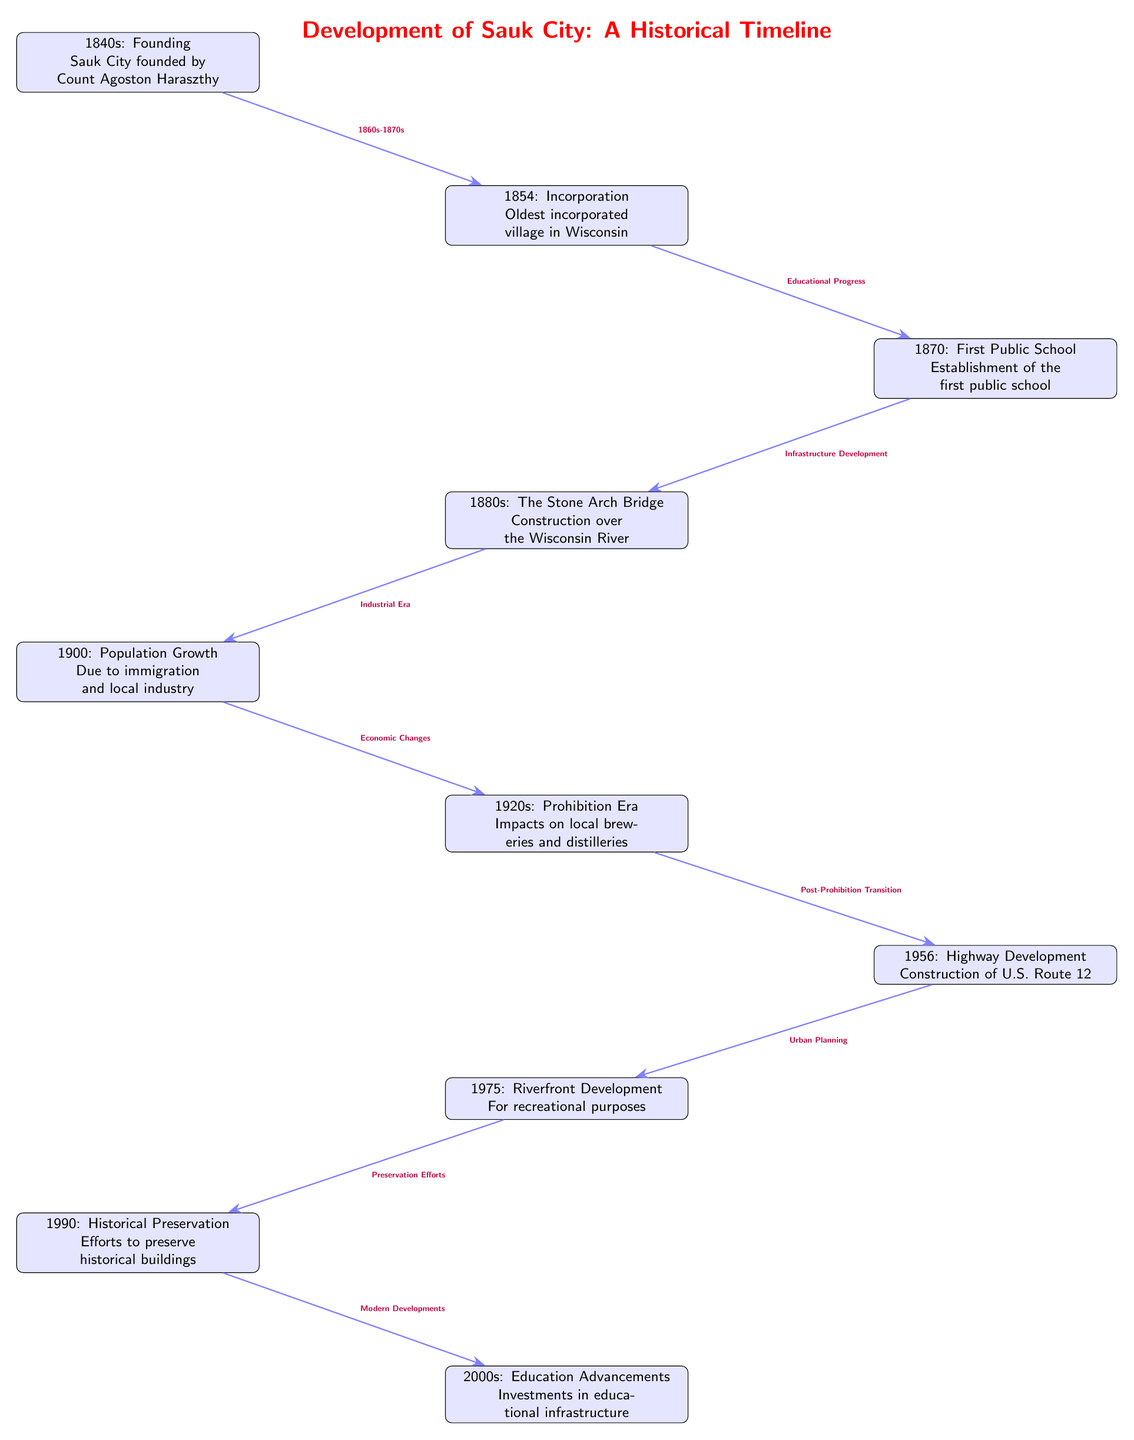What event marks the founding of Sauk City? The diagram identifies "1840s: Founding" as the event marking the founding, attributed to Count Agoston Haraszthy.
Answer: Founding When was Sauk City incorporated? According to the diagram, Sauk City was incorporated in "1854".
Answer: 1854 What was the first public institution established in Sauk City? The diagram states that "1870: First Public School" marks the establishment of the first public school in the city.
Answer: First Public School Which significant construction occurred in the 1880s? The diagram notes "1880s: The Stone Arch Bridge" as a major construction project that took place over the Wisconsin River.
Answer: The Stone Arch Bridge How did immigration impact Sauk City around 1900? The diagram explains "1900: Population Growth" due to immigration and local industry as a significant factor in the city's growth at that time.
Answer: Population Growth What development occurred in Sauk City in the 1950s? The diagram highlights "1956: Highway Development" as a notable event with the construction of U.S. Route 12.
Answer: Highway Development What were the effects of the 1920s on local businesses? The diagram states that during the "1920s: Prohibition Era", local breweries and distilleries were impacted.
Answer: Impacts on local breweries and distilleries What progression of events connects public education to infrastructure? In the diagram, the flow is from "1854: Incorporation" leading to "Educational Progress" followed by "Infrastructure Development" with the establishment of the first public school in 1870. This shows how the incorporation led to focus on education which in turn demanded infrastructure improvements.
Answer: Educational Progress to Infrastructure Development What key focus emerged in Sauk City during the 1990s? The diagram shows that "1990: Historical Preservation" highlights efforts to maintain historical buildings, reflecting a growing awareness of the importance of heritage.
Answer: Historical Preservation How did urban planning evolve from highway development in the 1950s to riverfront development in the 1970s? The diagram illustrates that after the "1956: Highway Development", which provided transportation infrastructure, the subsequent "Urban Planning" led to "1975: Riverfront Development" emphasizing the importance of recreational spaces in urban environments. This connection demonstrates a shift from vehicular development to community-oriented spaces.
Answer: Urban Planning to Riverfront Development 